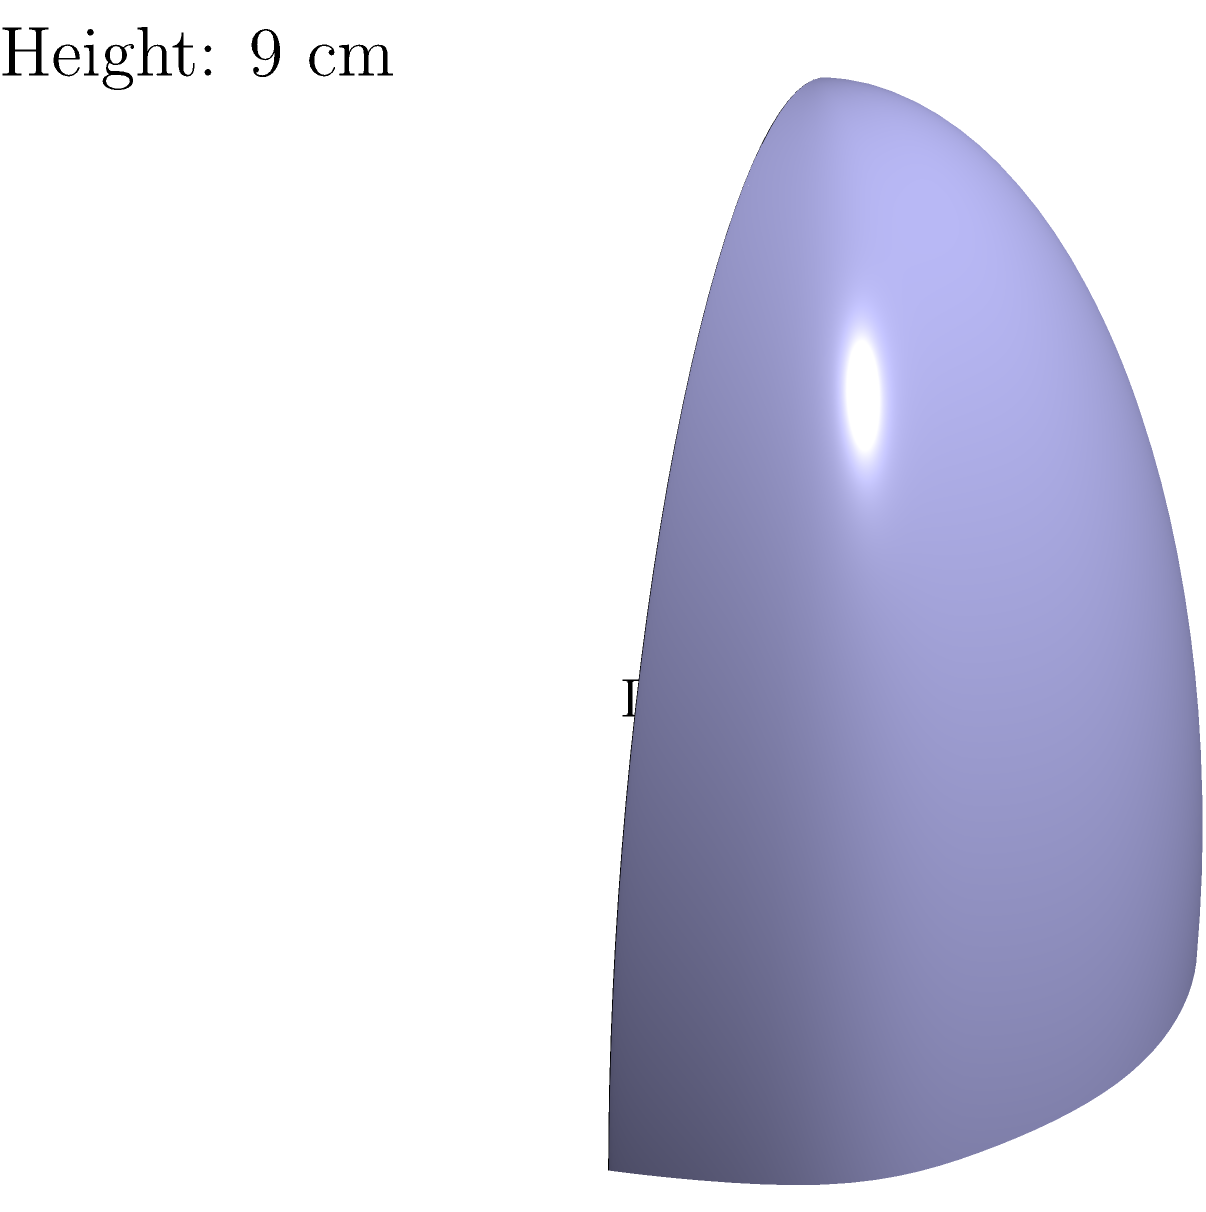Shakira wants to create a unique guitar-shaped container for her new perfume line. The container can be approximated as an ellipsoid with dimensions 6 cm in length, 3 cm in width, and 9 cm in height. What is the volume of this guitar-shaped container in cubic centimeters? To find the volume of the guitar-shaped container (ellipsoid), we can use the formula for the volume of an ellipsoid:

$$V = \frac{4}{3}\pi abc$$

Where:
$a$ = half of the length
$b$ = half of the width
$c$ = half of the height

Let's plug in the values:

$a = 6 \div 2 = 3$ cm
$b = 3 \div 2 = 1.5$ cm
$c = 9 \div 2 = 4.5$ cm

Now, let's calculate the volume:

$$\begin{align*}
V &= \frac{4}{3}\pi (3)(1.5)(4.5) \\
&= \frac{4}{3}\pi (20.25) \\
&= 26.81\pi \\
&\approx 84.23 \text{ cm}^3
\end{align*}$$

Rounding to the nearest whole number, we get 84 cubic centimeters.
Answer: 84 cm³ 